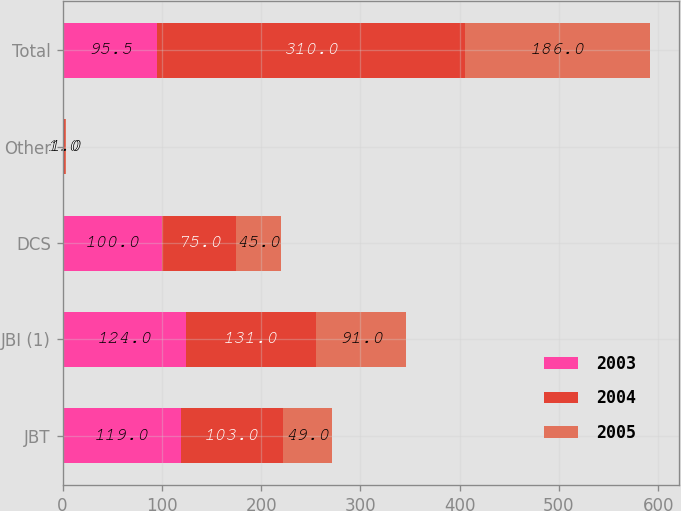<chart> <loc_0><loc_0><loc_500><loc_500><stacked_bar_chart><ecel><fcel>JBT<fcel>JBI (1)<fcel>DCS<fcel>Other<fcel>Total<nl><fcel>2003<fcel>119<fcel>124<fcel>100<fcel>1<fcel>95.5<nl><fcel>2004<fcel>103<fcel>131<fcel>75<fcel>1<fcel>310<nl><fcel>2005<fcel>49<fcel>91<fcel>45<fcel>1<fcel>186<nl></chart> 